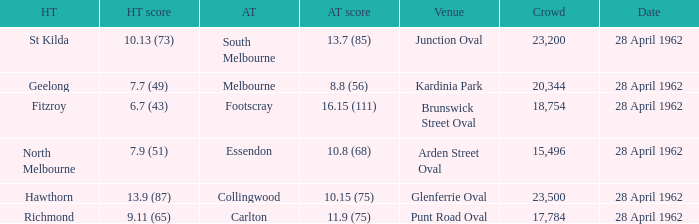What was the crowd size when there was a home team score of 10.13 (73)? 23200.0. 